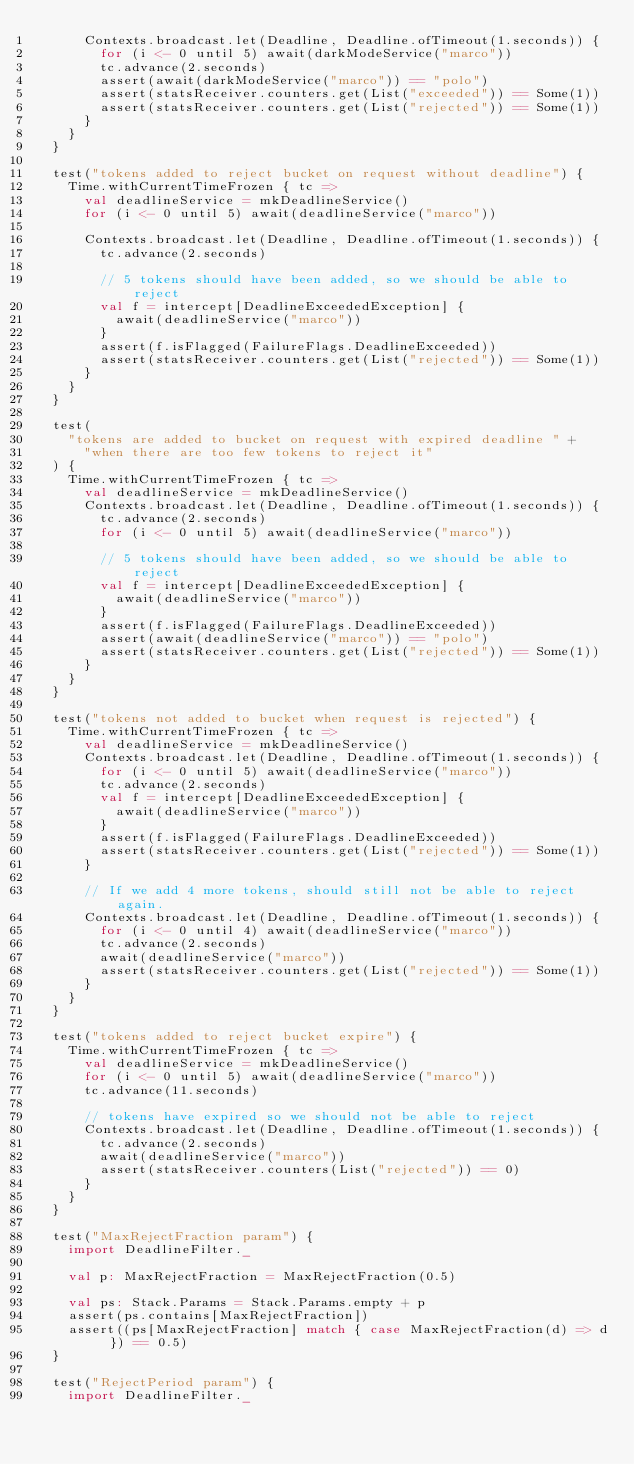<code> <loc_0><loc_0><loc_500><loc_500><_Scala_>      Contexts.broadcast.let(Deadline, Deadline.ofTimeout(1.seconds)) {
        for (i <- 0 until 5) await(darkModeService("marco"))
        tc.advance(2.seconds)
        assert(await(darkModeService("marco")) == "polo")
        assert(statsReceiver.counters.get(List("exceeded")) == Some(1))
        assert(statsReceiver.counters.get(List("rejected")) == Some(1))
      }
    }
  }

  test("tokens added to reject bucket on request without deadline") {
    Time.withCurrentTimeFrozen { tc =>
      val deadlineService = mkDeadlineService()
      for (i <- 0 until 5) await(deadlineService("marco"))

      Contexts.broadcast.let(Deadline, Deadline.ofTimeout(1.seconds)) {
        tc.advance(2.seconds)

        // 5 tokens should have been added, so we should be able to reject
        val f = intercept[DeadlineExceededException] {
          await(deadlineService("marco"))
        }
        assert(f.isFlagged(FailureFlags.DeadlineExceeded))
        assert(statsReceiver.counters.get(List("rejected")) == Some(1))
      }
    }
  }

  test(
    "tokens are added to bucket on request with expired deadline " +
      "when there are too few tokens to reject it"
  ) {
    Time.withCurrentTimeFrozen { tc =>
      val deadlineService = mkDeadlineService()
      Contexts.broadcast.let(Deadline, Deadline.ofTimeout(1.seconds)) {
        tc.advance(2.seconds)
        for (i <- 0 until 5) await(deadlineService("marco"))

        // 5 tokens should have been added, so we should be able to reject
        val f = intercept[DeadlineExceededException] {
          await(deadlineService("marco"))
        }
        assert(f.isFlagged(FailureFlags.DeadlineExceeded))
        assert(await(deadlineService("marco")) == "polo")
        assert(statsReceiver.counters.get(List("rejected")) == Some(1))
      }
    }
  }

  test("tokens not added to bucket when request is rejected") {
    Time.withCurrentTimeFrozen { tc =>
      val deadlineService = mkDeadlineService()
      Contexts.broadcast.let(Deadline, Deadline.ofTimeout(1.seconds)) {
        for (i <- 0 until 5) await(deadlineService("marco"))
        tc.advance(2.seconds)
        val f = intercept[DeadlineExceededException] {
          await(deadlineService("marco"))
        }
        assert(f.isFlagged(FailureFlags.DeadlineExceeded))
        assert(statsReceiver.counters.get(List("rejected")) == Some(1))
      }

      // If we add 4 more tokens, should still not be able to reject again.
      Contexts.broadcast.let(Deadline, Deadline.ofTimeout(1.seconds)) {
        for (i <- 0 until 4) await(deadlineService("marco"))
        tc.advance(2.seconds)
        await(deadlineService("marco"))
        assert(statsReceiver.counters.get(List("rejected")) == Some(1))
      }
    }
  }

  test("tokens added to reject bucket expire") {
    Time.withCurrentTimeFrozen { tc =>
      val deadlineService = mkDeadlineService()
      for (i <- 0 until 5) await(deadlineService("marco"))
      tc.advance(11.seconds)

      // tokens have expired so we should not be able to reject
      Contexts.broadcast.let(Deadline, Deadline.ofTimeout(1.seconds)) {
        tc.advance(2.seconds)
        await(deadlineService("marco"))
        assert(statsReceiver.counters(List("rejected")) == 0)
      }
    }
  }

  test("MaxRejectFraction param") {
    import DeadlineFilter._

    val p: MaxRejectFraction = MaxRejectFraction(0.5)

    val ps: Stack.Params = Stack.Params.empty + p
    assert(ps.contains[MaxRejectFraction])
    assert((ps[MaxRejectFraction] match { case MaxRejectFraction(d) => d }) == 0.5)
  }

  test("RejectPeriod param") {
    import DeadlineFilter._
</code> 